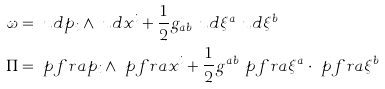Convert formula to latex. <formula><loc_0><loc_0><loc_500><loc_500>\omega & = \ u d p _ { i } \wedge \ u d x ^ { i } + \frac { 1 } { 2 } g _ { a b } \ u d \xi ^ { a } \ u d \xi ^ { b } \\ \Pi & = \ p f r a { p _ { i } } \wedge \ p f r a { x ^ { i } } + \frac { 1 } { 2 } g ^ { a b } \ p f r a { \xi ^ { a } } \cdot \ p f r a { \xi ^ { b } }</formula> 